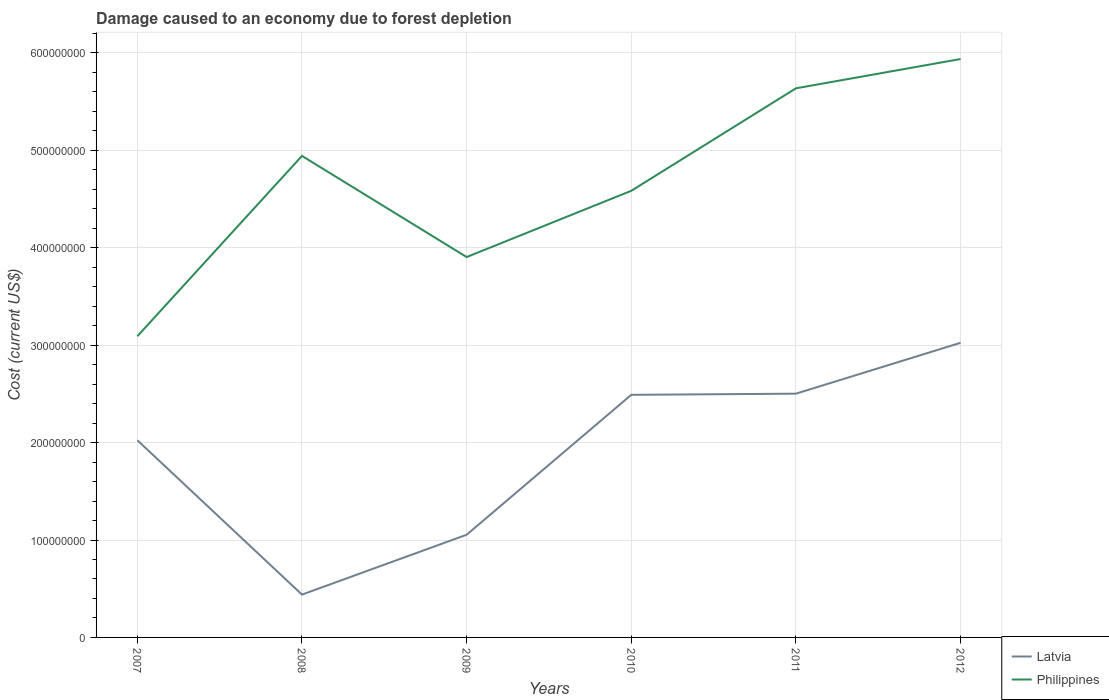How many different coloured lines are there?
Ensure brevity in your answer.  2. Is the number of lines equal to the number of legend labels?
Give a very brief answer. Yes. Across all years, what is the maximum cost of damage caused due to forest depletion in Latvia?
Your answer should be very brief. 4.40e+07. In which year was the cost of damage caused due to forest depletion in Philippines maximum?
Make the answer very short. 2007. What is the total cost of damage caused due to forest depletion in Philippines in the graph?
Keep it short and to the point. -8.13e+07. What is the difference between the highest and the second highest cost of damage caused due to forest depletion in Latvia?
Offer a terse response. 2.58e+08. What is the difference between the highest and the lowest cost of damage caused due to forest depletion in Latvia?
Make the answer very short. 4. Is the cost of damage caused due to forest depletion in Latvia strictly greater than the cost of damage caused due to forest depletion in Philippines over the years?
Your response must be concise. Yes. How many years are there in the graph?
Your answer should be very brief. 6. What is the difference between two consecutive major ticks on the Y-axis?
Give a very brief answer. 1.00e+08. Does the graph contain grids?
Provide a short and direct response. Yes. Where does the legend appear in the graph?
Offer a terse response. Bottom right. How many legend labels are there?
Your answer should be very brief. 2. What is the title of the graph?
Your answer should be compact. Damage caused to an economy due to forest depletion. Does "Indonesia" appear as one of the legend labels in the graph?
Provide a succinct answer. No. What is the label or title of the Y-axis?
Offer a very short reply. Cost (current US$). What is the Cost (current US$) in Latvia in 2007?
Make the answer very short. 2.02e+08. What is the Cost (current US$) of Philippines in 2007?
Give a very brief answer. 3.09e+08. What is the Cost (current US$) of Latvia in 2008?
Provide a succinct answer. 4.40e+07. What is the Cost (current US$) of Philippines in 2008?
Offer a very short reply. 4.94e+08. What is the Cost (current US$) in Latvia in 2009?
Give a very brief answer. 1.05e+08. What is the Cost (current US$) in Philippines in 2009?
Offer a terse response. 3.90e+08. What is the Cost (current US$) of Latvia in 2010?
Ensure brevity in your answer.  2.49e+08. What is the Cost (current US$) of Philippines in 2010?
Keep it short and to the point. 4.58e+08. What is the Cost (current US$) in Latvia in 2011?
Offer a terse response. 2.50e+08. What is the Cost (current US$) in Philippines in 2011?
Your answer should be compact. 5.64e+08. What is the Cost (current US$) in Latvia in 2012?
Keep it short and to the point. 3.02e+08. What is the Cost (current US$) in Philippines in 2012?
Offer a terse response. 5.94e+08. Across all years, what is the maximum Cost (current US$) in Latvia?
Your answer should be compact. 3.02e+08. Across all years, what is the maximum Cost (current US$) of Philippines?
Provide a succinct answer. 5.94e+08. Across all years, what is the minimum Cost (current US$) of Latvia?
Keep it short and to the point. 4.40e+07. Across all years, what is the minimum Cost (current US$) of Philippines?
Provide a succinct answer. 3.09e+08. What is the total Cost (current US$) of Latvia in the graph?
Your answer should be very brief. 1.15e+09. What is the total Cost (current US$) of Philippines in the graph?
Offer a very short reply. 2.81e+09. What is the difference between the Cost (current US$) in Latvia in 2007 and that in 2008?
Provide a short and direct response. 1.58e+08. What is the difference between the Cost (current US$) in Philippines in 2007 and that in 2008?
Make the answer very short. -1.85e+08. What is the difference between the Cost (current US$) in Latvia in 2007 and that in 2009?
Keep it short and to the point. 9.70e+07. What is the difference between the Cost (current US$) in Philippines in 2007 and that in 2009?
Give a very brief answer. -8.13e+07. What is the difference between the Cost (current US$) of Latvia in 2007 and that in 2010?
Offer a very short reply. -4.66e+07. What is the difference between the Cost (current US$) of Philippines in 2007 and that in 2010?
Provide a succinct answer. -1.49e+08. What is the difference between the Cost (current US$) in Latvia in 2007 and that in 2011?
Ensure brevity in your answer.  -4.78e+07. What is the difference between the Cost (current US$) of Philippines in 2007 and that in 2011?
Offer a very short reply. -2.55e+08. What is the difference between the Cost (current US$) in Latvia in 2007 and that in 2012?
Your answer should be very brief. -1.00e+08. What is the difference between the Cost (current US$) of Philippines in 2007 and that in 2012?
Offer a very short reply. -2.85e+08. What is the difference between the Cost (current US$) in Latvia in 2008 and that in 2009?
Make the answer very short. -6.14e+07. What is the difference between the Cost (current US$) in Philippines in 2008 and that in 2009?
Keep it short and to the point. 1.04e+08. What is the difference between the Cost (current US$) in Latvia in 2008 and that in 2010?
Offer a very short reply. -2.05e+08. What is the difference between the Cost (current US$) of Philippines in 2008 and that in 2010?
Ensure brevity in your answer.  3.58e+07. What is the difference between the Cost (current US$) in Latvia in 2008 and that in 2011?
Make the answer very short. -2.06e+08. What is the difference between the Cost (current US$) of Philippines in 2008 and that in 2011?
Provide a succinct answer. -6.94e+07. What is the difference between the Cost (current US$) in Latvia in 2008 and that in 2012?
Provide a succinct answer. -2.58e+08. What is the difference between the Cost (current US$) of Philippines in 2008 and that in 2012?
Your response must be concise. -9.95e+07. What is the difference between the Cost (current US$) of Latvia in 2009 and that in 2010?
Offer a terse response. -1.44e+08. What is the difference between the Cost (current US$) of Philippines in 2009 and that in 2010?
Provide a succinct answer. -6.80e+07. What is the difference between the Cost (current US$) in Latvia in 2009 and that in 2011?
Ensure brevity in your answer.  -1.45e+08. What is the difference between the Cost (current US$) of Philippines in 2009 and that in 2011?
Your answer should be very brief. -1.73e+08. What is the difference between the Cost (current US$) of Latvia in 2009 and that in 2012?
Provide a short and direct response. -1.97e+08. What is the difference between the Cost (current US$) of Philippines in 2009 and that in 2012?
Make the answer very short. -2.03e+08. What is the difference between the Cost (current US$) of Latvia in 2010 and that in 2011?
Provide a short and direct response. -1.18e+06. What is the difference between the Cost (current US$) of Philippines in 2010 and that in 2011?
Ensure brevity in your answer.  -1.05e+08. What is the difference between the Cost (current US$) in Latvia in 2010 and that in 2012?
Give a very brief answer. -5.34e+07. What is the difference between the Cost (current US$) in Philippines in 2010 and that in 2012?
Your response must be concise. -1.35e+08. What is the difference between the Cost (current US$) in Latvia in 2011 and that in 2012?
Ensure brevity in your answer.  -5.22e+07. What is the difference between the Cost (current US$) in Philippines in 2011 and that in 2012?
Provide a short and direct response. -3.01e+07. What is the difference between the Cost (current US$) in Latvia in 2007 and the Cost (current US$) in Philippines in 2008?
Your response must be concise. -2.92e+08. What is the difference between the Cost (current US$) in Latvia in 2007 and the Cost (current US$) in Philippines in 2009?
Make the answer very short. -1.88e+08. What is the difference between the Cost (current US$) of Latvia in 2007 and the Cost (current US$) of Philippines in 2010?
Your answer should be very brief. -2.56e+08. What is the difference between the Cost (current US$) in Latvia in 2007 and the Cost (current US$) in Philippines in 2011?
Provide a short and direct response. -3.61e+08. What is the difference between the Cost (current US$) of Latvia in 2007 and the Cost (current US$) of Philippines in 2012?
Keep it short and to the point. -3.91e+08. What is the difference between the Cost (current US$) of Latvia in 2008 and the Cost (current US$) of Philippines in 2009?
Make the answer very short. -3.47e+08. What is the difference between the Cost (current US$) of Latvia in 2008 and the Cost (current US$) of Philippines in 2010?
Keep it short and to the point. -4.15e+08. What is the difference between the Cost (current US$) of Latvia in 2008 and the Cost (current US$) of Philippines in 2011?
Your answer should be very brief. -5.20e+08. What is the difference between the Cost (current US$) of Latvia in 2008 and the Cost (current US$) of Philippines in 2012?
Your answer should be compact. -5.50e+08. What is the difference between the Cost (current US$) in Latvia in 2009 and the Cost (current US$) in Philippines in 2010?
Make the answer very short. -3.53e+08. What is the difference between the Cost (current US$) of Latvia in 2009 and the Cost (current US$) of Philippines in 2011?
Ensure brevity in your answer.  -4.58e+08. What is the difference between the Cost (current US$) of Latvia in 2009 and the Cost (current US$) of Philippines in 2012?
Keep it short and to the point. -4.88e+08. What is the difference between the Cost (current US$) of Latvia in 2010 and the Cost (current US$) of Philippines in 2011?
Your response must be concise. -3.15e+08. What is the difference between the Cost (current US$) in Latvia in 2010 and the Cost (current US$) in Philippines in 2012?
Keep it short and to the point. -3.45e+08. What is the difference between the Cost (current US$) in Latvia in 2011 and the Cost (current US$) in Philippines in 2012?
Offer a terse response. -3.44e+08. What is the average Cost (current US$) of Latvia per year?
Offer a terse response. 1.92e+08. What is the average Cost (current US$) of Philippines per year?
Provide a short and direct response. 4.68e+08. In the year 2007, what is the difference between the Cost (current US$) of Latvia and Cost (current US$) of Philippines?
Your answer should be compact. -1.07e+08. In the year 2008, what is the difference between the Cost (current US$) of Latvia and Cost (current US$) of Philippines?
Your answer should be compact. -4.50e+08. In the year 2009, what is the difference between the Cost (current US$) of Latvia and Cost (current US$) of Philippines?
Your answer should be very brief. -2.85e+08. In the year 2010, what is the difference between the Cost (current US$) of Latvia and Cost (current US$) of Philippines?
Provide a short and direct response. -2.09e+08. In the year 2011, what is the difference between the Cost (current US$) of Latvia and Cost (current US$) of Philippines?
Provide a succinct answer. -3.13e+08. In the year 2012, what is the difference between the Cost (current US$) of Latvia and Cost (current US$) of Philippines?
Ensure brevity in your answer.  -2.91e+08. What is the ratio of the Cost (current US$) in Latvia in 2007 to that in 2008?
Make the answer very short. 4.6. What is the ratio of the Cost (current US$) in Philippines in 2007 to that in 2008?
Make the answer very short. 0.63. What is the ratio of the Cost (current US$) in Latvia in 2007 to that in 2009?
Make the answer very short. 1.92. What is the ratio of the Cost (current US$) in Philippines in 2007 to that in 2009?
Provide a succinct answer. 0.79. What is the ratio of the Cost (current US$) in Latvia in 2007 to that in 2010?
Provide a short and direct response. 0.81. What is the ratio of the Cost (current US$) in Philippines in 2007 to that in 2010?
Offer a very short reply. 0.67. What is the ratio of the Cost (current US$) of Latvia in 2007 to that in 2011?
Ensure brevity in your answer.  0.81. What is the ratio of the Cost (current US$) of Philippines in 2007 to that in 2011?
Provide a succinct answer. 0.55. What is the ratio of the Cost (current US$) in Latvia in 2007 to that in 2012?
Make the answer very short. 0.67. What is the ratio of the Cost (current US$) of Philippines in 2007 to that in 2012?
Keep it short and to the point. 0.52. What is the ratio of the Cost (current US$) of Latvia in 2008 to that in 2009?
Your response must be concise. 0.42. What is the ratio of the Cost (current US$) of Philippines in 2008 to that in 2009?
Your answer should be very brief. 1.27. What is the ratio of the Cost (current US$) in Latvia in 2008 to that in 2010?
Offer a terse response. 0.18. What is the ratio of the Cost (current US$) of Philippines in 2008 to that in 2010?
Your answer should be compact. 1.08. What is the ratio of the Cost (current US$) of Latvia in 2008 to that in 2011?
Provide a short and direct response. 0.18. What is the ratio of the Cost (current US$) in Philippines in 2008 to that in 2011?
Offer a terse response. 0.88. What is the ratio of the Cost (current US$) in Latvia in 2008 to that in 2012?
Provide a succinct answer. 0.15. What is the ratio of the Cost (current US$) of Philippines in 2008 to that in 2012?
Provide a succinct answer. 0.83. What is the ratio of the Cost (current US$) of Latvia in 2009 to that in 2010?
Offer a terse response. 0.42. What is the ratio of the Cost (current US$) in Philippines in 2009 to that in 2010?
Your response must be concise. 0.85. What is the ratio of the Cost (current US$) in Latvia in 2009 to that in 2011?
Your response must be concise. 0.42. What is the ratio of the Cost (current US$) in Philippines in 2009 to that in 2011?
Your answer should be compact. 0.69. What is the ratio of the Cost (current US$) in Latvia in 2009 to that in 2012?
Keep it short and to the point. 0.35. What is the ratio of the Cost (current US$) of Philippines in 2009 to that in 2012?
Offer a very short reply. 0.66. What is the ratio of the Cost (current US$) of Latvia in 2010 to that in 2011?
Ensure brevity in your answer.  1. What is the ratio of the Cost (current US$) in Philippines in 2010 to that in 2011?
Ensure brevity in your answer.  0.81. What is the ratio of the Cost (current US$) of Latvia in 2010 to that in 2012?
Your response must be concise. 0.82. What is the ratio of the Cost (current US$) in Philippines in 2010 to that in 2012?
Give a very brief answer. 0.77. What is the ratio of the Cost (current US$) in Latvia in 2011 to that in 2012?
Your answer should be compact. 0.83. What is the ratio of the Cost (current US$) in Philippines in 2011 to that in 2012?
Offer a terse response. 0.95. What is the difference between the highest and the second highest Cost (current US$) in Latvia?
Offer a very short reply. 5.22e+07. What is the difference between the highest and the second highest Cost (current US$) in Philippines?
Your answer should be compact. 3.01e+07. What is the difference between the highest and the lowest Cost (current US$) in Latvia?
Keep it short and to the point. 2.58e+08. What is the difference between the highest and the lowest Cost (current US$) of Philippines?
Provide a short and direct response. 2.85e+08. 